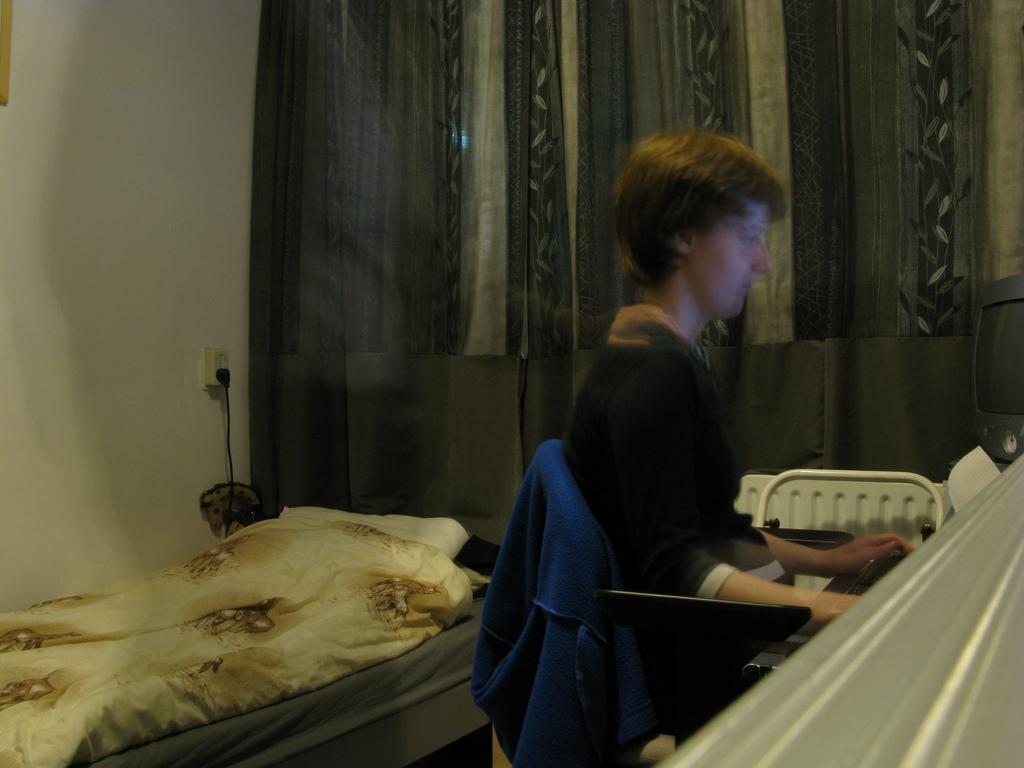Could you give a brief overview of what you see in this image? In this image we can see a person sitting on the chair and he is sitting in front of the computer. Here we can see the bed with mattress. Here we can see a bed sheet and a pillow on the bed. Here we can see the socket on the wall. In the background, we can see the curtains. 